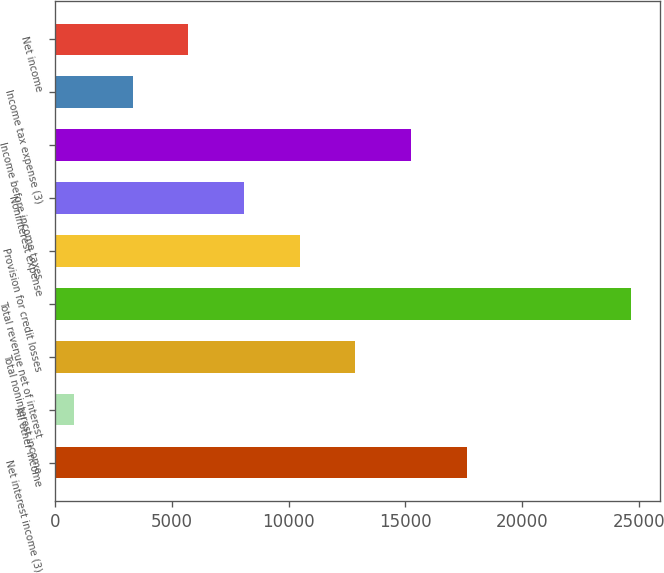Convert chart. <chart><loc_0><loc_0><loc_500><loc_500><bar_chart><fcel>Net interest income (3)<fcel>All other income<fcel>Total noninterest income<fcel>Total revenue net of interest<fcel>Provision for credit losses<fcel>Noninterest expense<fcel>Income before income taxes<fcel>Income tax expense (3)<fcel>Net income<nl><fcel>17618.2<fcel>819<fcel>12854.8<fcel>24636<fcel>10473.1<fcel>8091.4<fcel>15236.5<fcel>3328<fcel>5709.7<nl></chart> 